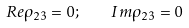Convert formula to latex. <formula><loc_0><loc_0><loc_500><loc_500>R e \rho _ { 2 3 } = 0 ; \quad I m \rho _ { 2 3 } = 0</formula> 